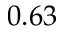<formula> <loc_0><loc_0><loc_500><loc_500>0 . 6 3</formula> 